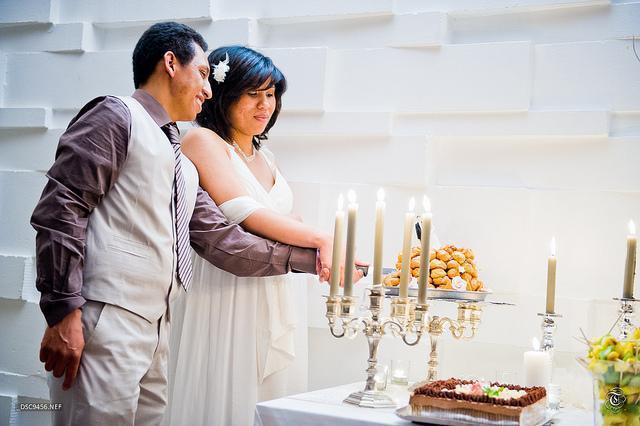How many people are visible?
Give a very brief answer. 2. How many faucets does the sink have?
Give a very brief answer. 0. 